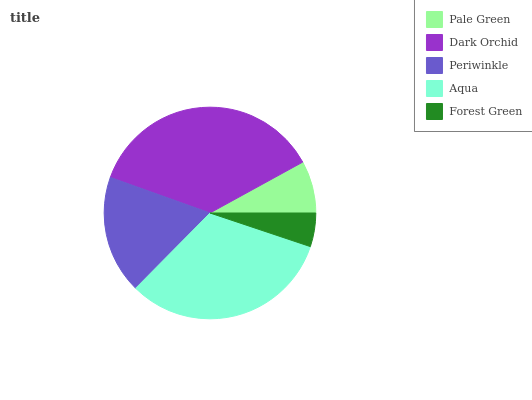Is Forest Green the minimum?
Answer yes or no. Yes. Is Dark Orchid the maximum?
Answer yes or no. Yes. Is Periwinkle the minimum?
Answer yes or no. No. Is Periwinkle the maximum?
Answer yes or no. No. Is Dark Orchid greater than Periwinkle?
Answer yes or no. Yes. Is Periwinkle less than Dark Orchid?
Answer yes or no. Yes. Is Periwinkle greater than Dark Orchid?
Answer yes or no. No. Is Dark Orchid less than Periwinkle?
Answer yes or no. No. Is Periwinkle the high median?
Answer yes or no. Yes. Is Periwinkle the low median?
Answer yes or no. Yes. Is Pale Green the high median?
Answer yes or no. No. Is Pale Green the low median?
Answer yes or no. No. 